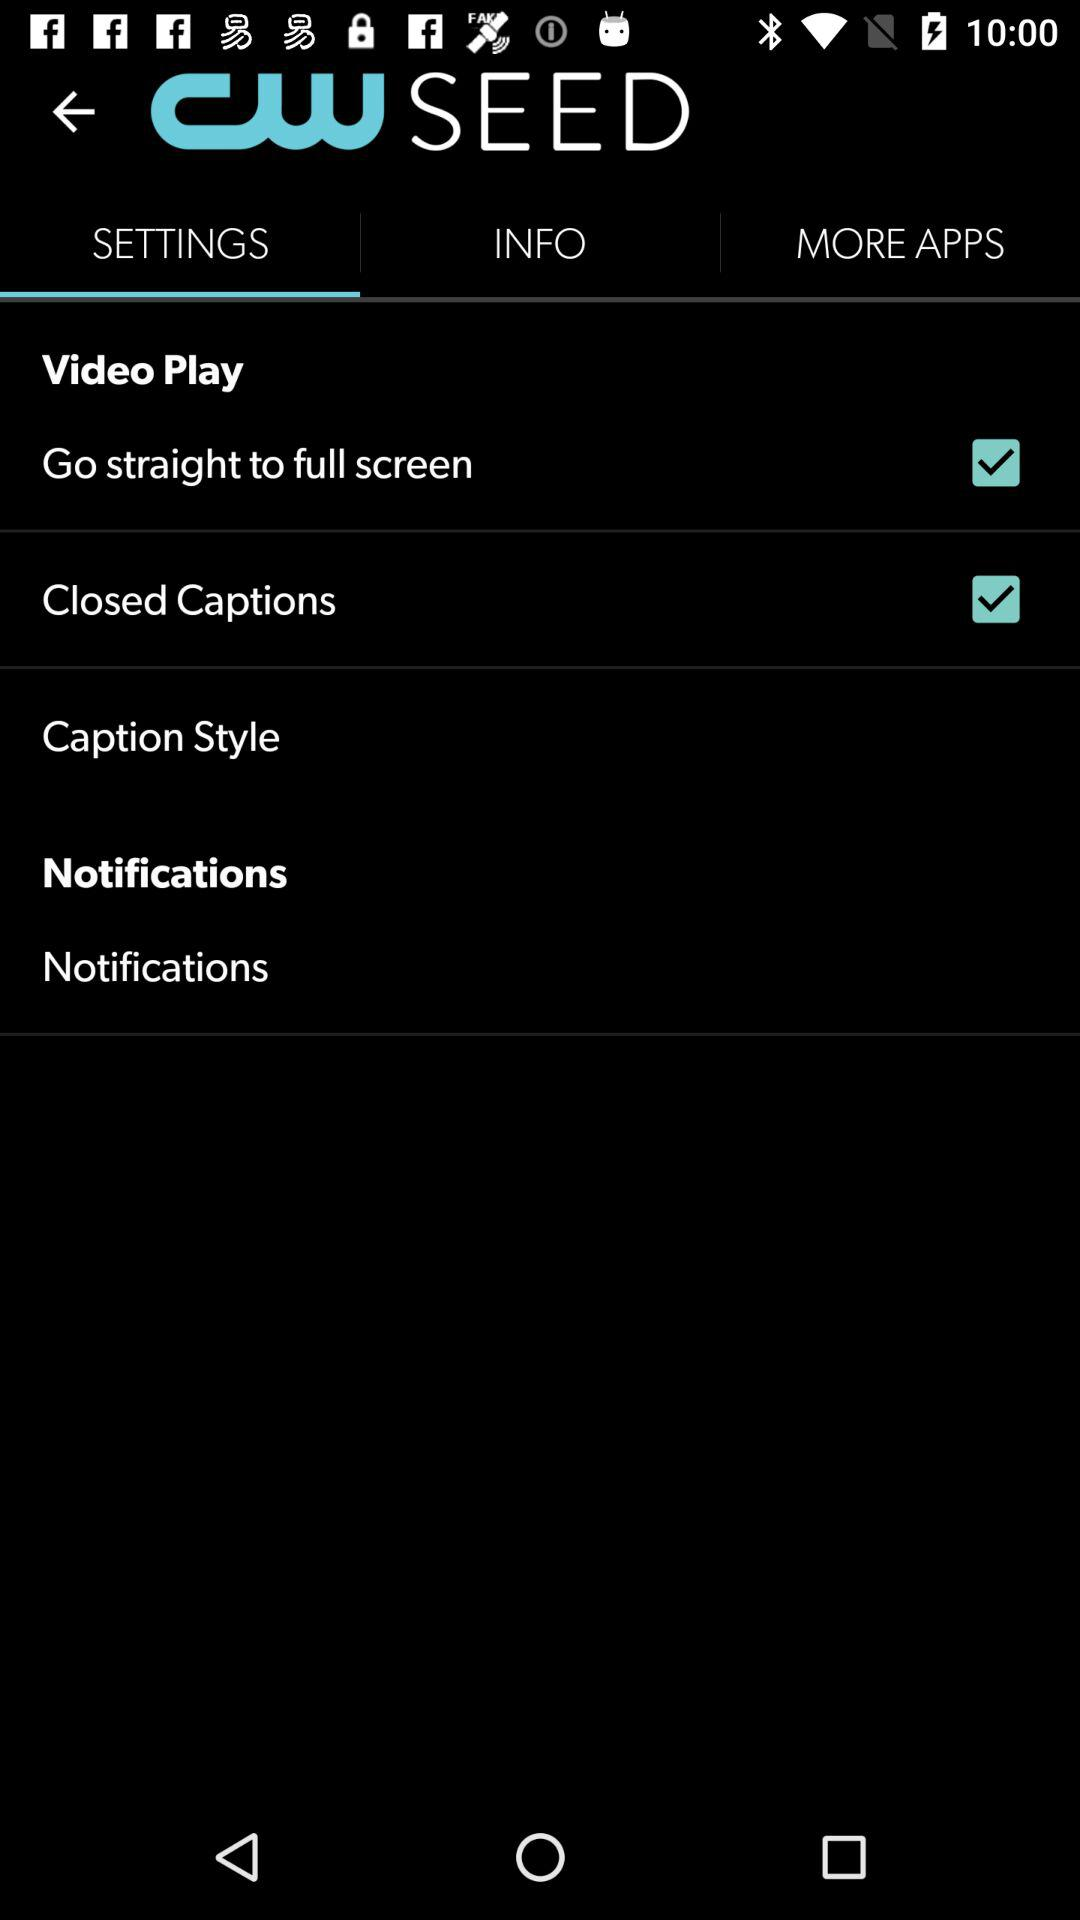What is the status of "Go straight to full screen"? The status is "on". 